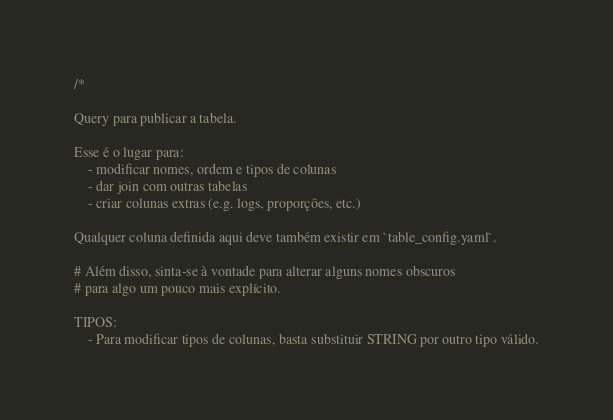<code> <loc_0><loc_0><loc_500><loc_500><_SQL_>/*

Query para publicar a tabela.

Esse é o lugar para:
    - modificar nomes, ordem e tipos de colunas
    - dar join com outras tabelas
    - criar colunas extras (e.g. logs, proporções, etc.)

Qualquer coluna definida aqui deve também existir em `table_config.yaml`.

# Além disso, sinta-se à vontade para alterar alguns nomes obscuros
# para algo um pouco mais explícito.

TIPOS:
    - Para modificar tipos de colunas, basta substituir STRING por outro tipo válido.</code> 